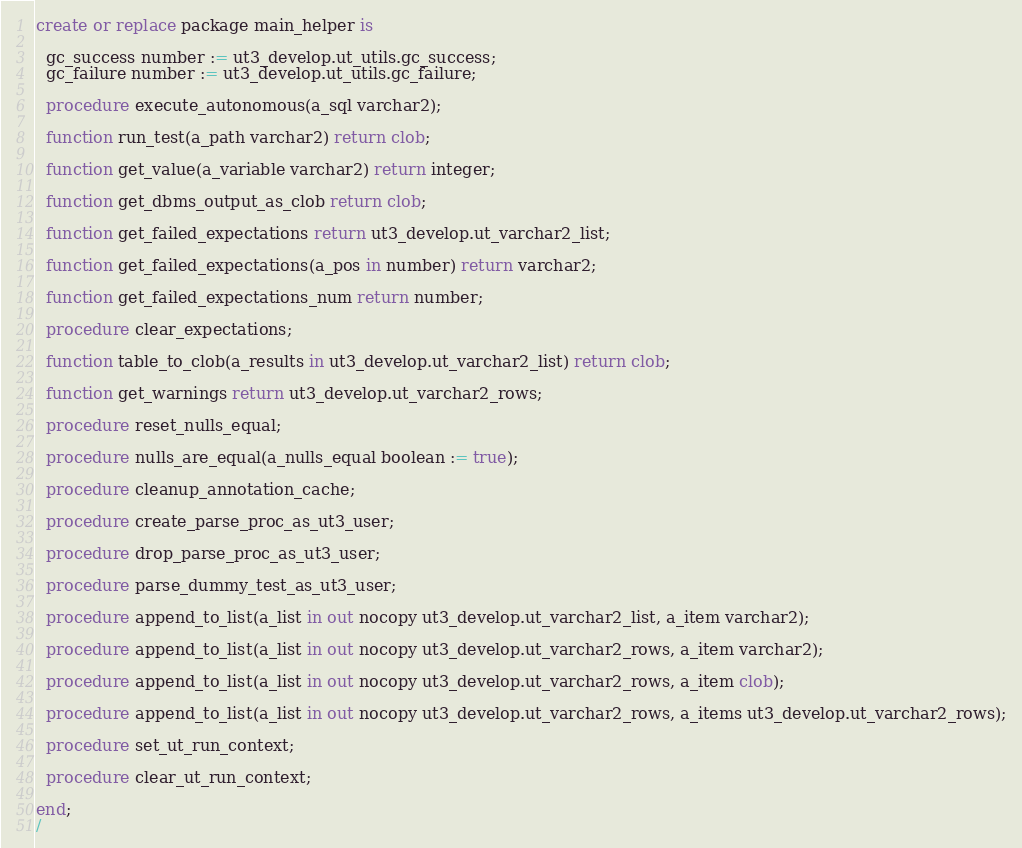Convert code to text. <code><loc_0><loc_0><loc_500><loc_500><_SQL_>create or replace package main_helper is

  gc_success number := ut3_develop.ut_utils.gc_success;
  gc_failure number := ut3_develop.ut_utils.gc_failure;

  procedure execute_autonomous(a_sql varchar2);

  function run_test(a_path varchar2) return clob;

  function get_value(a_variable varchar2) return integer;

  function get_dbms_output_as_clob return clob;
  
  function get_failed_expectations return ut3_develop.ut_varchar2_list;

  function get_failed_expectations(a_pos in number) return varchar2;
  
  function get_failed_expectations_num return number;
  
  procedure clear_expectations;
    
  function table_to_clob(a_results in ut3_develop.ut_varchar2_list) return clob;
  
  function get_warnings return ut3_develop.ut_varchar2_rows;
  
  procedure reset_nulls_equal;
  
  procedure nulls_are_equal(a_nulls_equal boolean := true);
  
  procedure cleanup_annotation_cache;
  
  procedure create_parse_proc_as_ut3_user;
  
  procedure drop_parse_proc_as_ut3_user;
  
  procedure parse_dummy_test_as_ut3_user;
  
  procedure append_to_list(a_list in out nocopy ut3_develop.ut_varchar2_list, a_item varchar2);

  procedure append_to_list(a_list in out nocopy ut3_develop.ut_varchar2_rows, a_item varchar2);

  procedure append_to_list(a_list in out nocopy ut3_develop.ut_varchar2_rows, a_item clob);

  procedure append_to_list(a_list in out nocopy ut3_develop.ut_varchar2_rows, a_items ut3_develop.ut_varchar2_rows);

  procedure set_ut_run_context;

  procedure clear_ut_run_context;
  
end;
/
</code> 